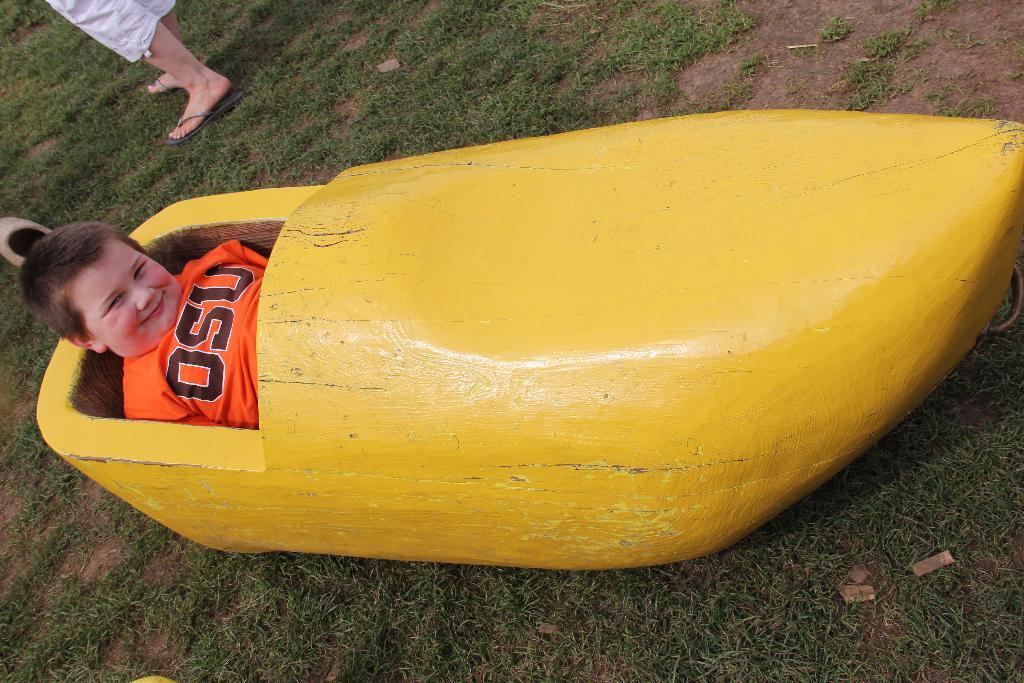Is this an osu shirt?
Make the answer very short. Yes. 